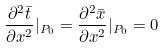Convert formula to latex. <formula><loc_0><loc_0><loc_500><loc_500>\frac { \partial ^ { 2 } \bar { t } } { \partial x ^ { 2 } } | _ { P _ { 0 } } = \frac { \partial ^ { 2 } \bar { x } } { \partial x ^ { 2 } } | _ { P _ { 0 } } = 0</formula> 